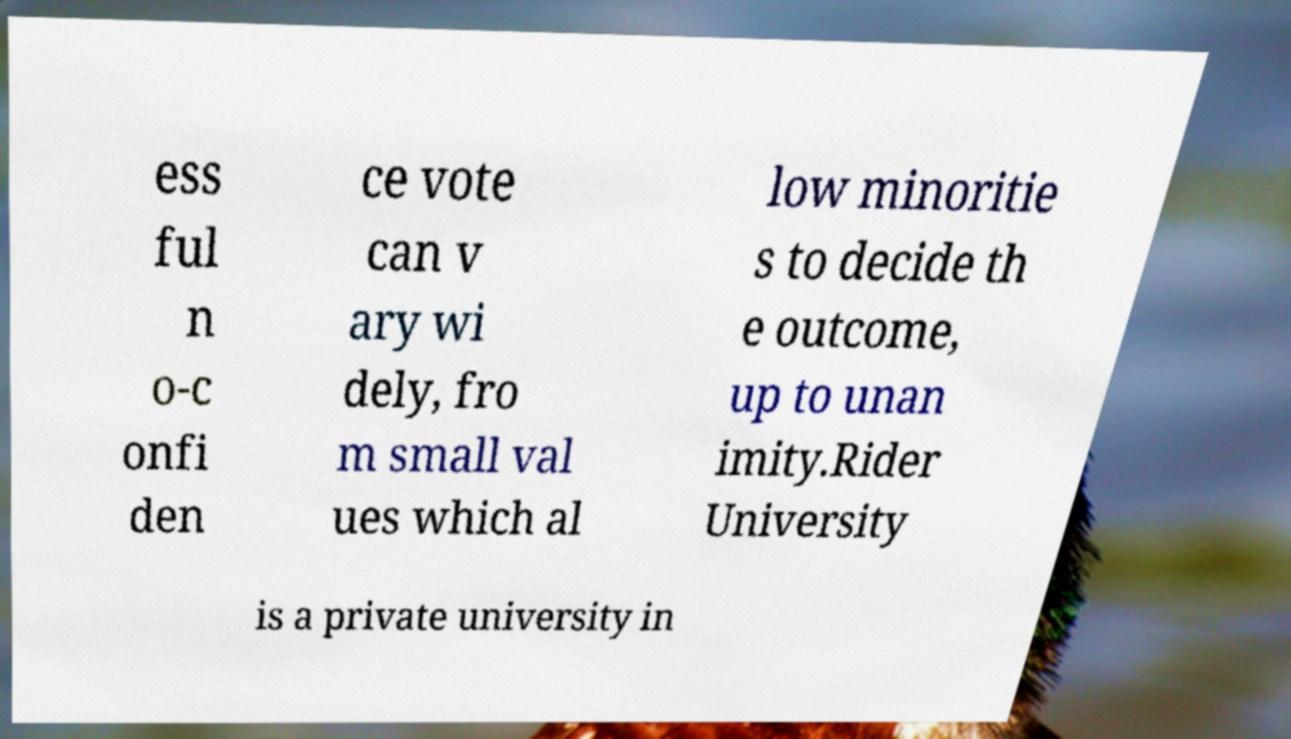Can you accurately transcribe the text from the provided image for me? ess ful n o-c onfi den ce vote can v ary wi dely, fro m small val ues which al low minoritie s to decide th e outcome, up to unan imity.Rider University is a private university in 